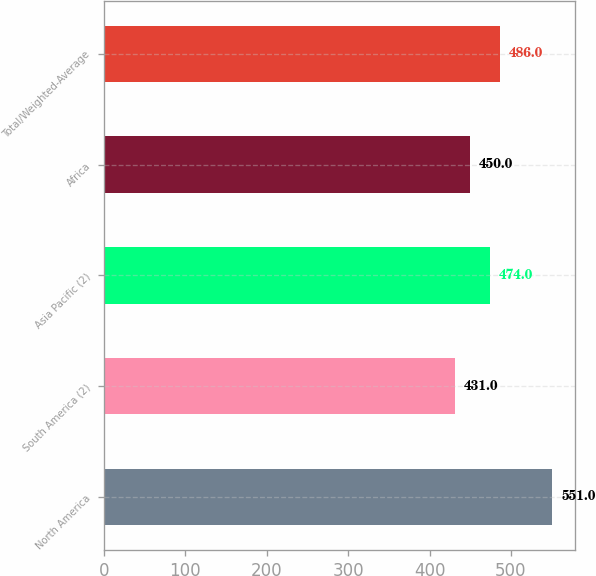Convert chart to OTSL. <chart><loc_0><loc_0><loc_500><loc_500><bar_chart><fcel>North America<fcel>South America (2)<fcel>Asia Pacific (2)<fcel>Africa<fcel>Total/Weighted-Average<nl><fcel>551<fcel>431<fcel>474<fcel>450<fcel>486<nl></chart> 